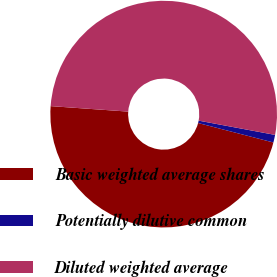Convert chart to OTSL. <chart><loc_0><loc_0><loc_500><loc_500><pie_chart><fcel>Basic weighted average shares<fcel>Potentially dilutive common<fcel>Diluted weighted average<nl><fcel>47.1%<fcel>1.09%<fcel>51.81%<nl></chart> 